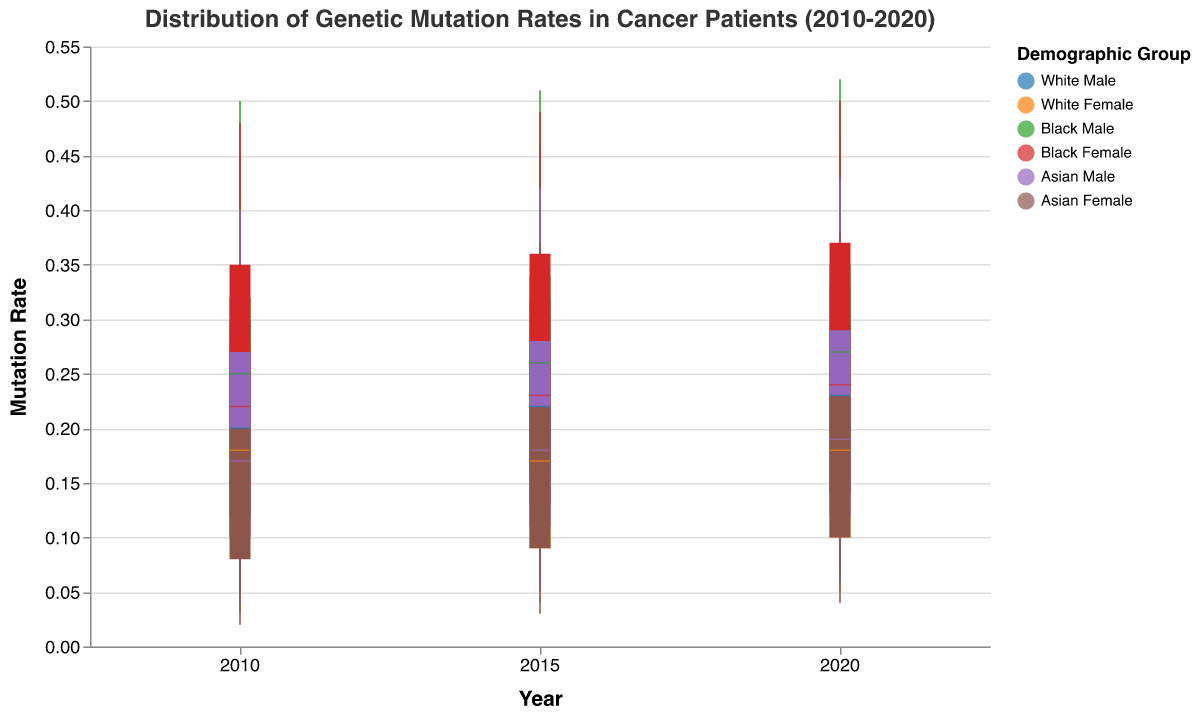What is the title of the figure? The title is located at the top of the figure and describes the overall topic of the plot.
Answer: Distribution of Genetic Mutation Rates in Cancer Patients (2010-2020) What is the median mutation rate for White Males in 2015? Look at the candlestick corresponding to White Males in the year 2015 and identify the tick mark representing the median value.
Answer: 0.22 Which demographic group had the highest mutation rate in 2020? Find the demographic group with the tallest vertical line extending to the highest value on the y-axis for the year 2020.
Answer: Black Male Between 2010 and 2020, which year saw the smallest range in mutation rates for Asian Females? Compare the lengths of the vertical lines (representing the range between the lowest and highest mutation rates) for Asian Females across the years 2010, 2015, and 2020.
Answer: 2010 How did the median mutation rate for Black Females change from 2010 to 2020? Identify the median values for Black Females in 2010 and 2020, then calculate the difference. For 2010, the median is 0.22 and for 2020, it is 0.24. The mutation rate increased by 0.02.
Answer: Increased by 0.02 Which demographic group consistently had the lowest mutation rate across all years? Identify the demographic group that has the lowest values on the lower end of the vertical lines for all years.
Answer: Asian Female In 2015, which demographic group had a higher upper quartile value: Black Males or White Males? Compare the upper quartile values (top of the colored bars) for Black Males and White Males in the year 2015. Black Males had an upper quartile of 0.34 compared to White Males' 0.32.
Answer: Black Male What is the trend in the median mutation rate for Asian Males from 2010 to 2020? Observe the median values for Asian Males for the years 2010, 2015, and 2020. The median values are 0.17 in 2010, 0.18 in 2015, and 0.19 in 2020, showing a gradual increase.
Answer: Increasing For White Females, what is the difference between the highest mutation rate in 2010 and 2020? Identify the highest mutation rates for White Females in 2010 and 2020. Calculate the difference by subtracting the highest rate in 2010 (0.42) from the highest rate in 2020 (0.43).
Answer: 0.01 What is the interquartile range of genetic mutation rates for Black Males in 2020? The interquartile range is calculated by subtracting the lower quartile (0.17) from the upper quartile (0.35).
Answer: 0.18 